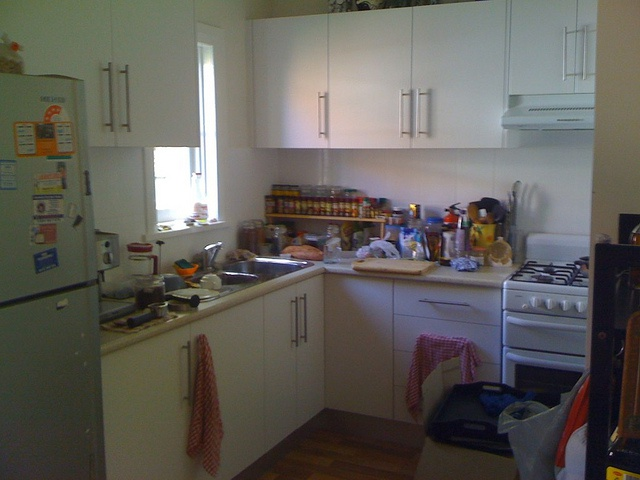Describe the objects in this image and their specific colors. I can see refrigerator in darkgreen, black, and gray tones, oven in darkgreen, gray, and black tones, sink in darkgreen, black, gray, and white tones, bottle in darkgreen, black, gray, darkgray, and purple tones, and bowl in darkgreen, maroon, and brown tones in this image. 